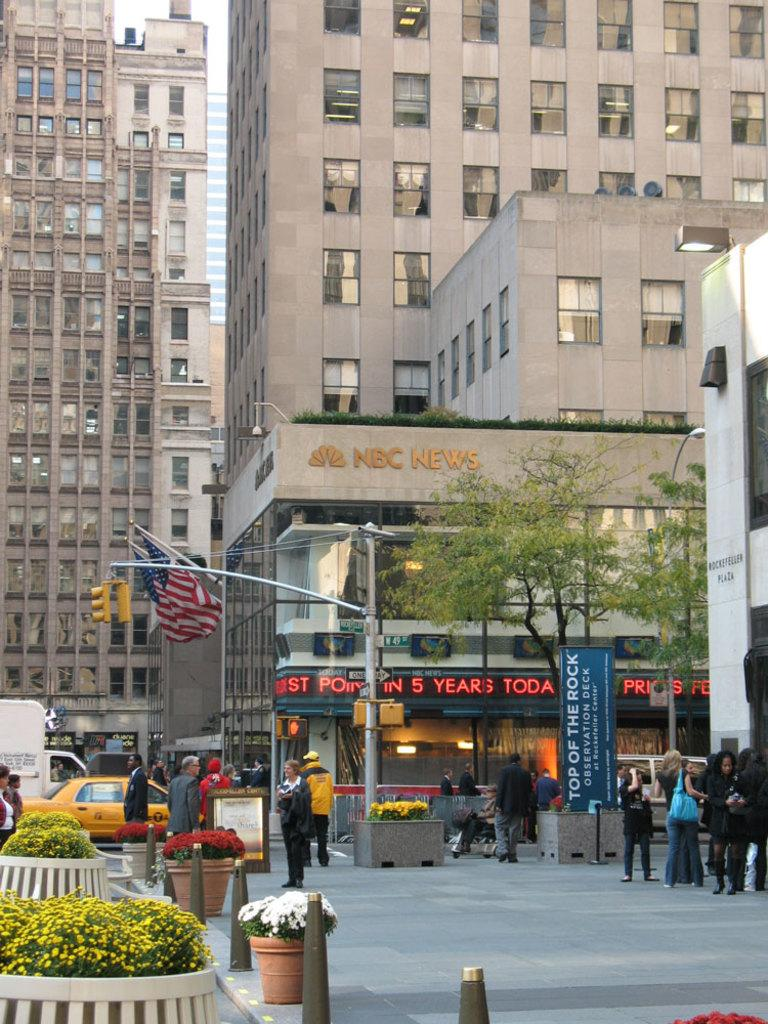<image>
Summarize the visual content of the image. NBC News sign is on the building in the background. 